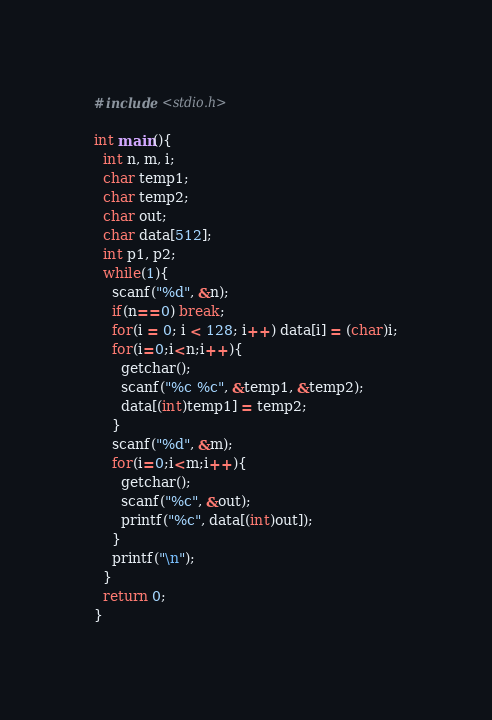Convert code to text. <code><loc_0><loc_0><loc_500><loc_500><_C_>#include <stdio.h>

int main(){
  int n, m, i;
  char temp1;
  char temp2;
  char out;
  char data[512];
  int p1, p2;
  while(1){
    scanf("%d", &n);
    if(n==0) break;
    for(i = 0; i < 128; i++) data[i] = (char)i;
    for(i=0;i<n;i++){
      getchar();
      scanf("%c %c", &temp1, &temp2);
      data[(int)temp1] = temp2;
    }
    scanf("%d", &m);
    for(i=0;i<m;i++){
      getchar();
      scanf("%c", &out);
      printf("%c", data[(int)out]);
    }
    printf("\n");
  }
  return 0;
}</code> 